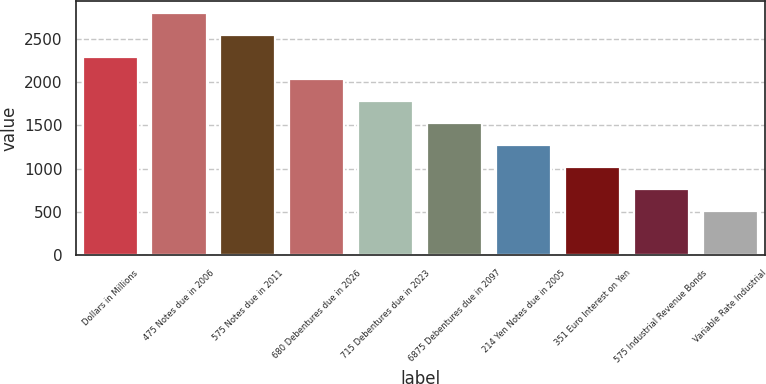Convert chart to OTSL. <chart><loc_0><loc_0><loc_500><loc_500><bar_chart><fcel>Dollars in Millions<fcel>475 Notes due in 2006<fcel>575 Notes due in 2011<fcel>680 Debentures due in 2026<fcel>715 Debentures due in 2023<fcel>6875 Debentures due in 2097<fcel>214 Yen Notes due in 2005<fcel>351 Euro Interest on Yen<fcel>575 Industrial Revenue Bonds<fcel>Variable Rate Industrial<nl><fcel>2289.7<fcel>2798.3<fcel>2544<fcel>2035.4<fcel>1781.1<fcel>1526.8<fcel>1272.5<fcel>1018.2<fcel>763.9<fcel>509.6<nl></chart> 